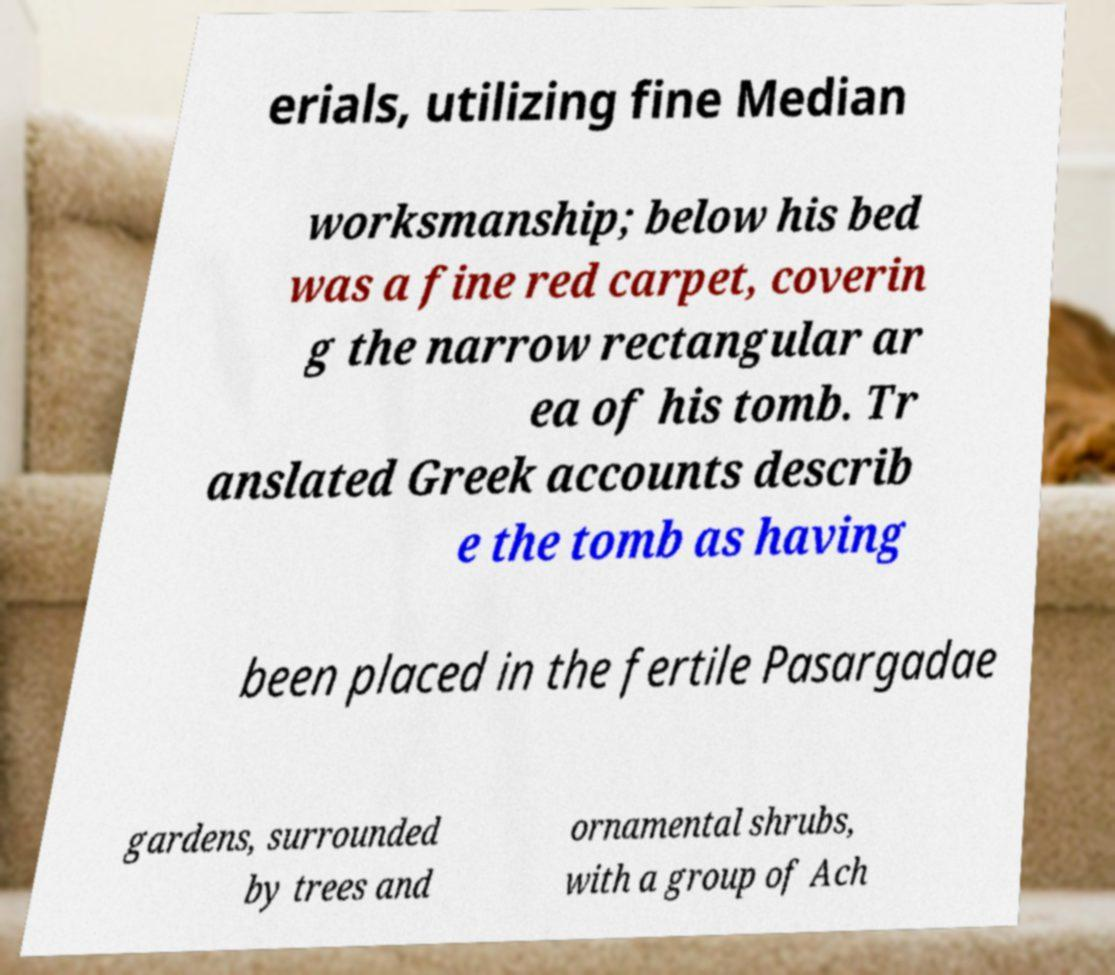Please identify and transcribe the text found in this image. erials, utilizing fine Median worksmanship; below his bed was a fine red carpet, coverin g the narrow rectangular ar ea of his tomb. Tr anslated Greek accounts describ e the tomb as having been placed in the fertile Pasargadae gardens, surrounded by trees and ornamental shrubs, with a group of Ach 